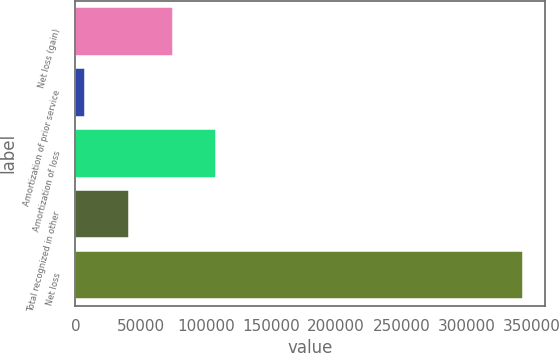Convert chart. <chart><loc_0><loc_0><loc_500><loc_500><bar_chart><fcel>Net loss (gain)<fcel>Amortization of prior service<fcel>Amortization of loss<fcel>Total recognized in other<fcel>Net loss<nl><fcel>74566<fcel>7364<fcel>108167<fcel>40965<fcel>343374<nl></chart> 